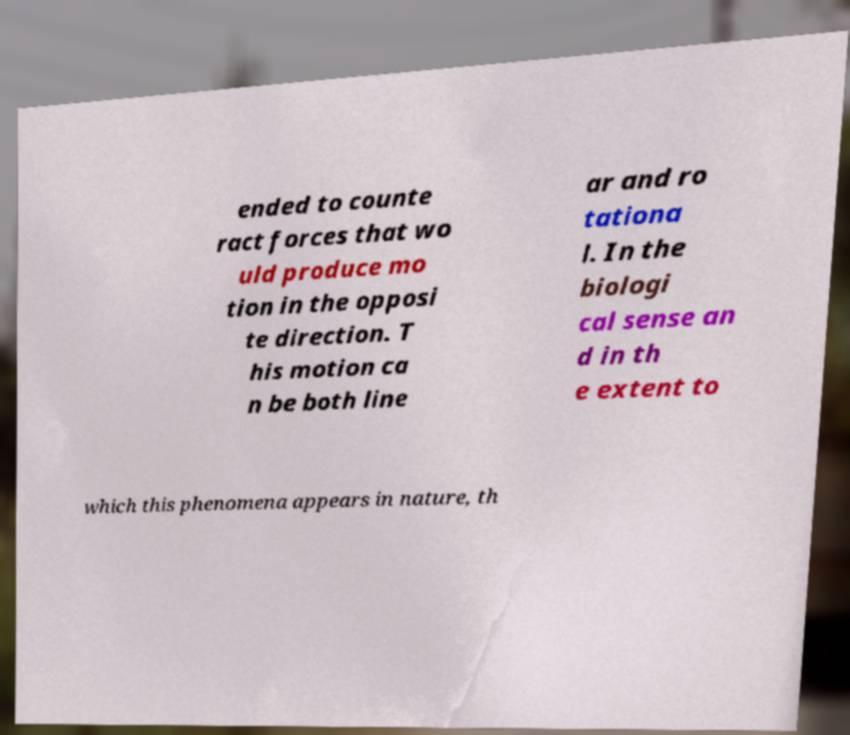What messages or text are displayed in this image? I need them in a readable, typed format. ended to counte ract forces that wo uld produce mo tion in the opposi te direction. T his motion ca n be both line ar and ro tationa l. In the biologi cal sense an d in th e extent to which this phenomena appears in nature, th 